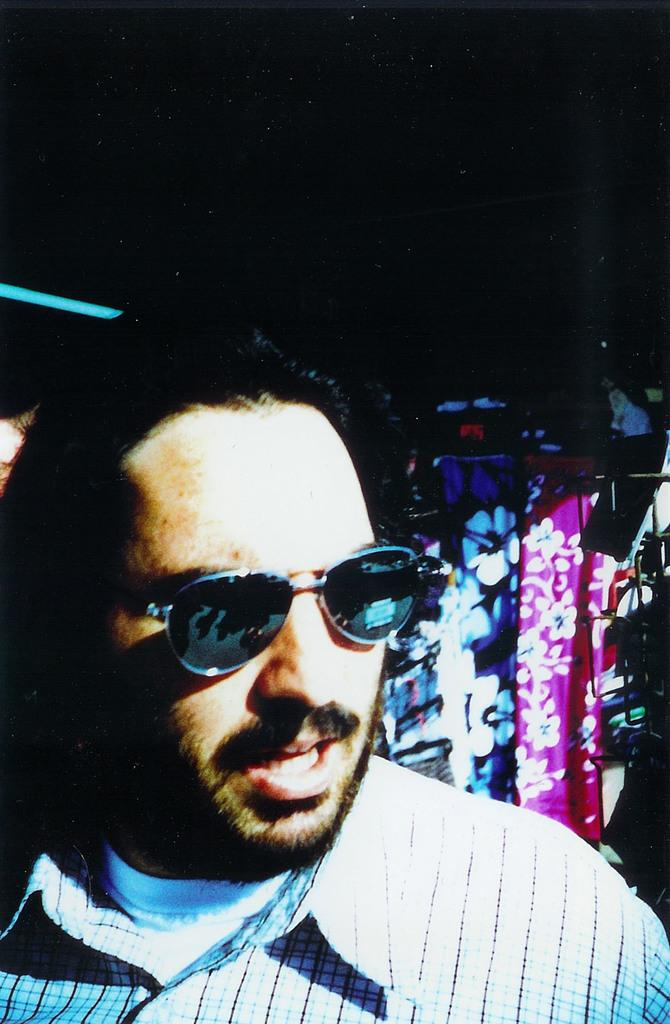Who is present in the image? There is a man in the image. What is the man doing in the image? The man is talking in the image. Can you describe the man's clothing? The man is wearing a shirt and spectacles in the image. What can be seen on the right side of the image? There is a cloth in purple color and another cloth with flowers on the right side of the image. What type of shade is covering the man in the image? There is no shade covering the man in the image; he is not under any shelter or protection from the sun. 